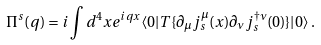<formula> <loc_0><loc_0><loc_500><loc_500>\Pi ^ { s } ( q ) = i \int d ^ { 4 } x e ^ { i q x } \langle 0 | T \{ \partial _ { \mu } j ^ { \mu } _ { s } ( x ) \partial _ { \nu } j ^ { \dagger \nu } _ { s } ( 0 ) \} | 0 \rangle \, .</formula> 